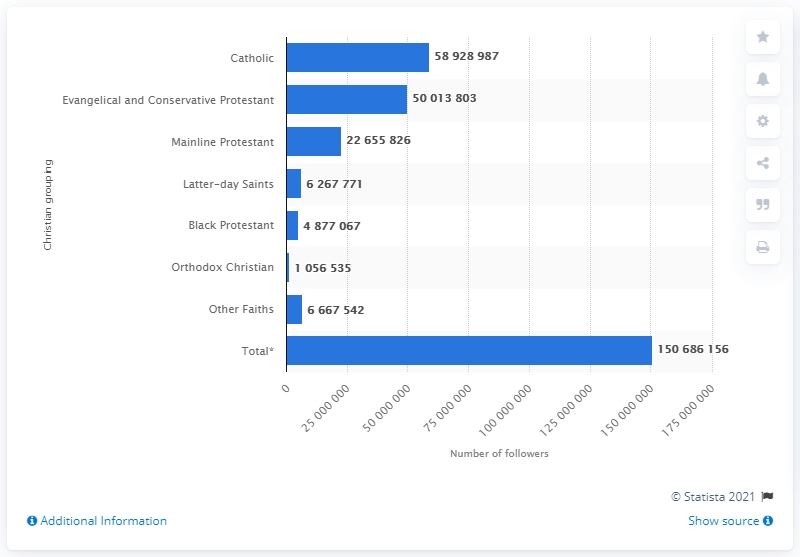Mention a couple of crucial points in this snapshot. In 2010, there were approximately 626,771 members of the Church of Jesus Christ of Latter-day Saints. 